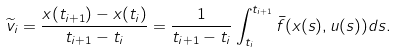Convert formula to latex. <formula><loc_0><loc_0><loc_500><loc_500>\widetilde { v } _ { i } = \frac { x ( t _ { i + 1 } ) - x ( t _ { i } ) } { t _ { i + 1 } - t _ { i } } = \frac { 1 } { t _ { i + 1 } - t _ { i } } \int _ { t _ { i } } ^ { t _ { i + 1 } } \bar { f } ( x ( s ) , u ( s ) ) d s .</formula> 